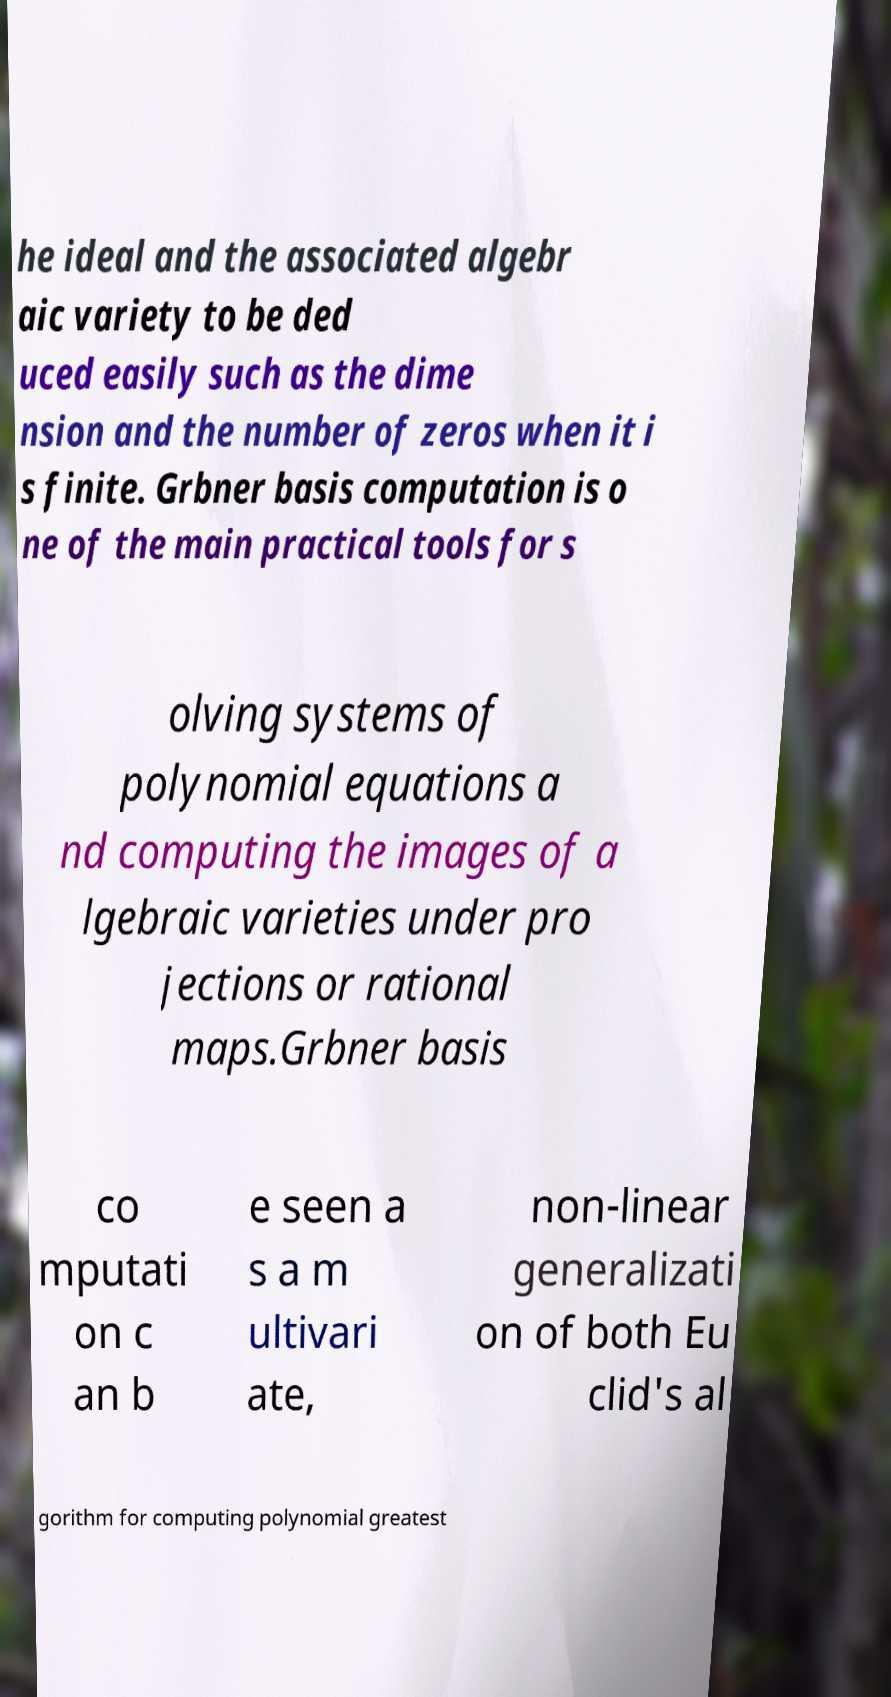I need the written content from this picture converted into text. Can you do that? he ideal and the associated algebr aic variety to be ded uced easily such as the dime nsion and the number of zeros when it i s finite. Grbner basis computation is o ne of the main practical tools for s olving systems of polynomial equations a nd computing the images of a lgebraic varieties under pro jections or rational maps.Grbner basis co mputati on c an b e seen a s a m ultivari ate, non-linear generalizati on of both Eu clid's al gorithm for computing polynomial greatest 